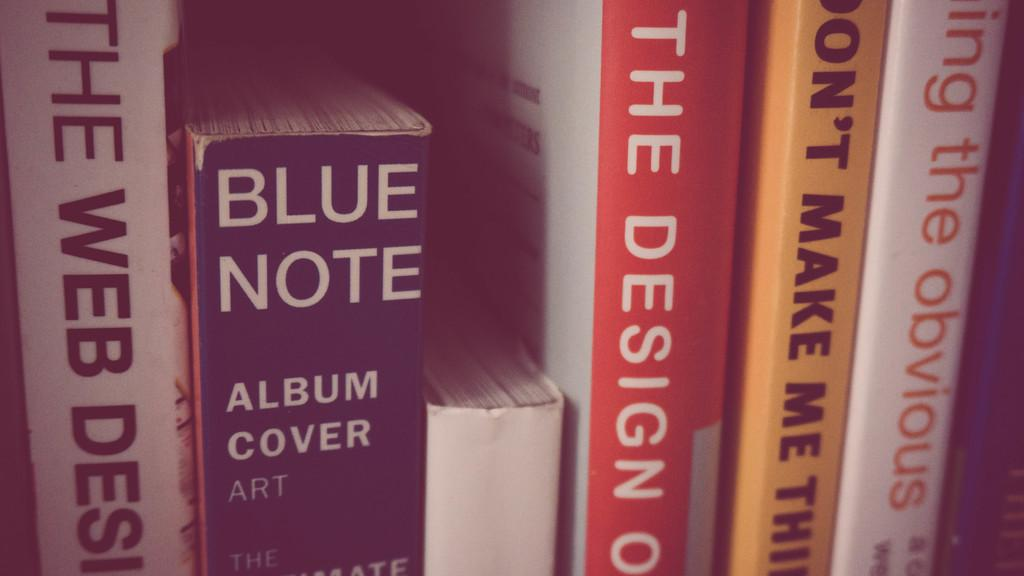<image>
Give a short and clear explanation of the subsequent image. several books including blue note, an album cover art 